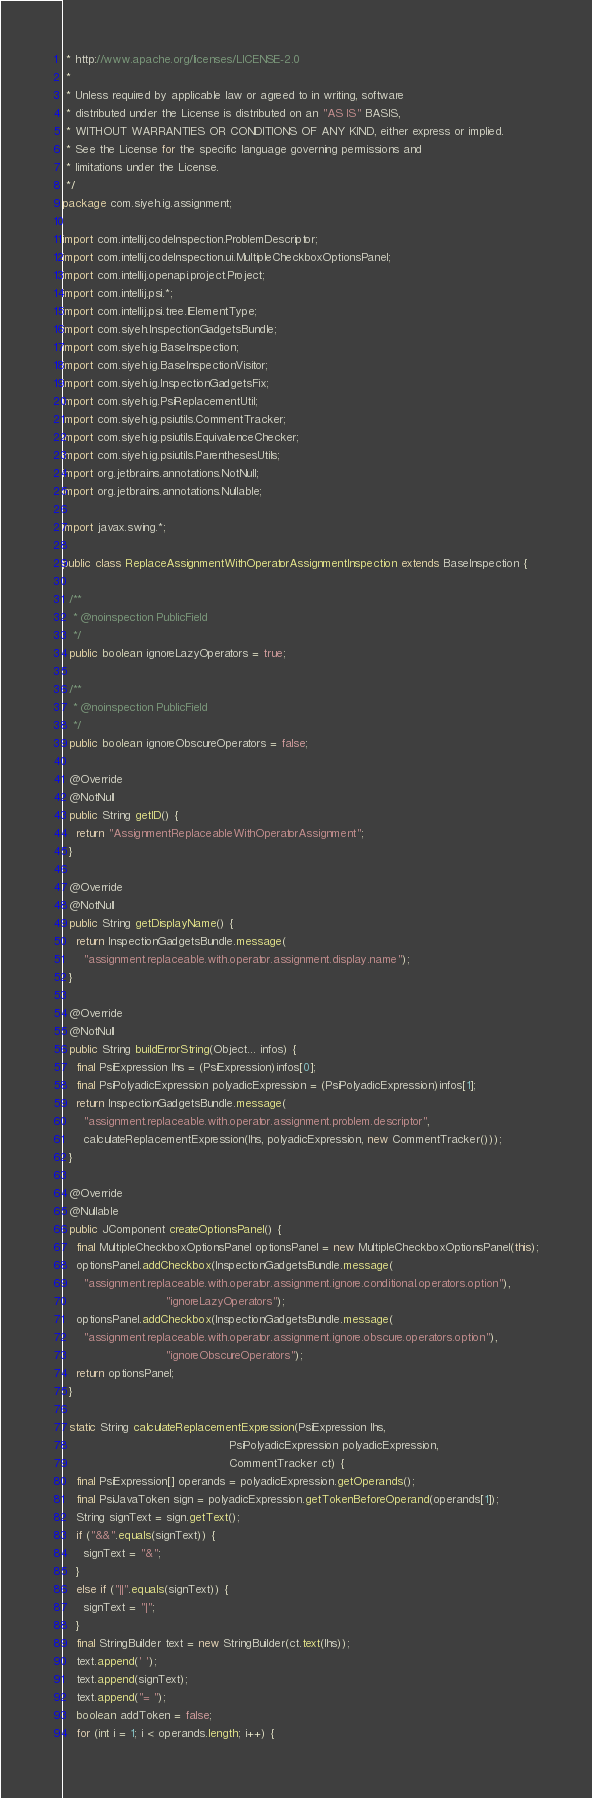Convert code to text. <code><loc_0><loc_0><loc_500><loc_500><_Java_> * http://www.apache.org/licenses/LICENSE-2.0
 *
 * Unless required by applicable law or agreed to in writing, software
 * distributed under the License is distributed on an "AS IS" BASIS,
 * WITHOUT WARRANTIES OR CONDITIONS OF ANY KIND, either express or implied.
 * See the License for the specific language governing permissions and
 * limitations under the License.
 */
package com.siyeh.ig.assignment;

import com.intellij.codeInspection.ProblemDescriptor;
import com.intellij.codeInspection.ui.MultipleCheckboxOptionsPanel;
import com.intellij.openapi.project.Project;
import com.intellij.psi.*;
import com.intellij.psi.tree.IElementType;
import com.siyeh.InspectionGadgetsBundle;
import com.siyeh.ig.BaseInspection;
import com.siyeh.ig.BaseInspectionVisitor;
import com.siyeh.ig.InspectionGadgetsFix;
import com.siyeh.ig.PsiReplacementUtil;
import com.siyeh.ig.psiutils.CommentTracker;
import com.siyeh.ig.psiutils.EquivalenceChecker;
import com.siyeh.ig.psiutils.ParenthesesUtils;
import org.jetbrains.annotations.NotNull;
import org.jetbrains.annotations.Nullable;

import javax.swing.*;

public class ReplaceAssignmentWithOperatorAssignmentInspection extends BaseInspection {

  /**
   * @noinspection PublicField
   */
  public boolean ignoreLazyOperators = true;

  /**
   * @noinspection PublicField
   */
  public boolean ignoreObscureOperators = false;

  @Override
  @NotNull
  public String getID() {
    return "AssignmentReplaceableWithOperatorAssignment";
  }

  @Override
  @NotNull
  public String getDisplayName() {
    return InspectionGadgetsBundle.message(
      "assignment.replaceable.with.operator.assignment.display.name");
  }

  @Override
  @NotNull
  public String buildErrorString(Object... infos) {
    final PsiExpression lhs = (PsiExpression)infos[0];
    final PsiPolyadicExpression polyadicExpression = (PsiPolyadicExpression)infos[1];
    return InspectionGadgetsBundle.message(
      "assignment.replaceable.with.operator.assignment.problem.descriptor",
      calculateReplacementExpression(lhs, polyadicExpression, new CommentTracker()));
  }

  @Override
  @Nullable
  public JComponent createOptionsPanel() {
    final MultipleCheckboxOptionsPanel optionsPanel = new MultipleCheckboxOptionsPanel(this);
    optionsPanel.addCheckbox(InspectionGadgetsBundle.message(
      "assignment.replaceable.with.operator.assignment.ignore.conditional.operators.option"),
                             "ignoreLazyOperators");
    optionsPanel.addCheckbox(InspectionGadgetsBundle.message(
      "assignment.replaceable.with.operator.assignment.ignore.obscure.operators.option"),
                             "ignoreObscureOperators");
    return optionsPanel;
  }

  static String calculateReplacementExpression(PsiExpression lhs,
                                               PsiPolyadicExpression polyadicExpression,
                                               CommentTracker ct) {
    final PsiExpression[] operands = polyadicExpression.getOperands();
    final PsiJavaToken sign = polyadicExpression.getTokenBeforeOperand(operands[1]);
    String signText = sign.getText();
    if ("&&".equals(signText)) {
      signText = "&";
    }
    else if ("||".equals(signText)) {
      signText = "|";
    }
    final StringBuilder text = new StringBuilder(ct.text(lhs));
    text.append(' ');
    text.append(signText);
    text.append("= ");
    boolean addToken = false;
    for (int i = 1; i < operands.length; i++) {</code> 